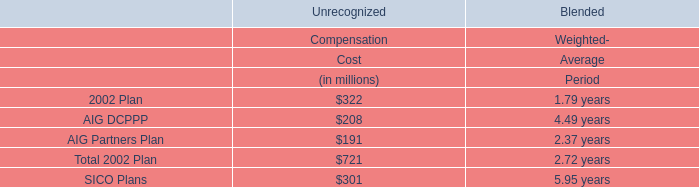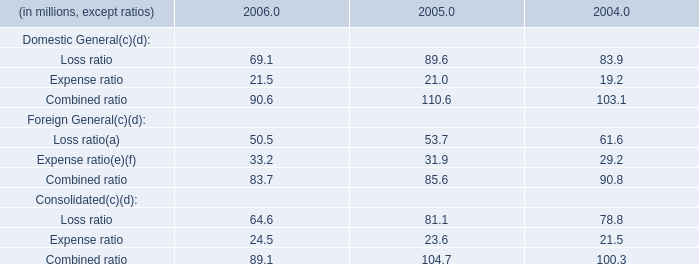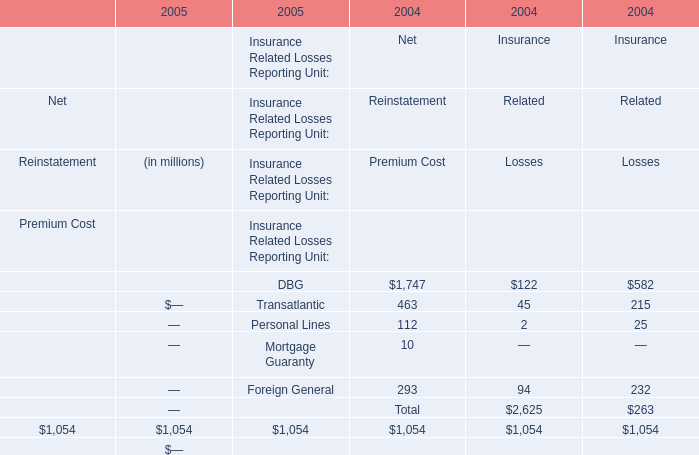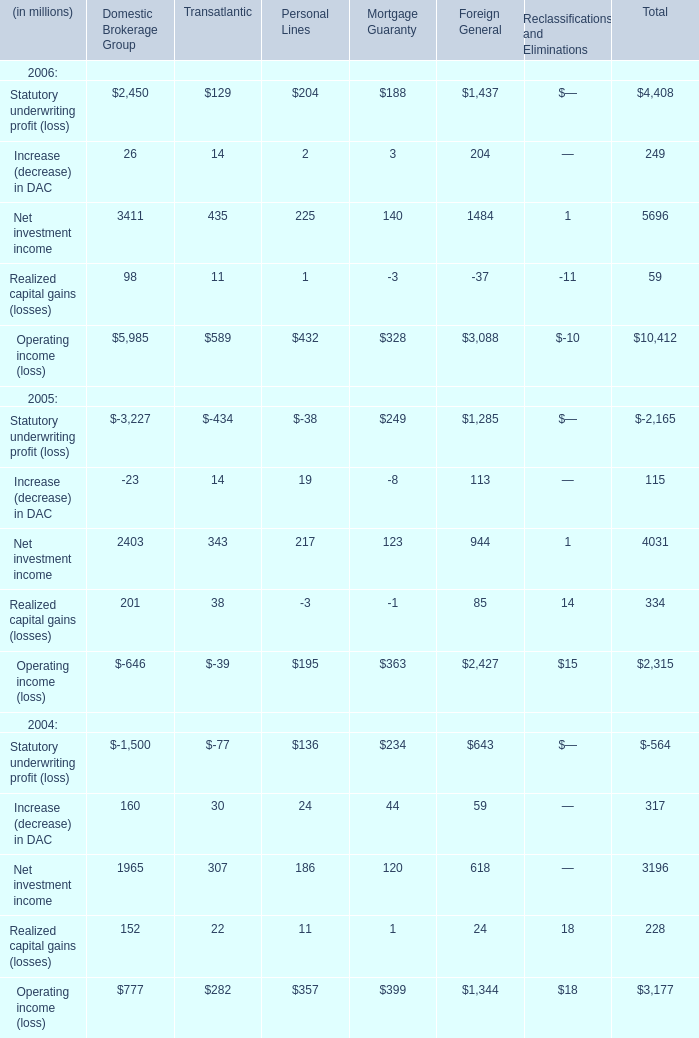Which year is Loss ratio of Consolidated the lowest? 
Answer: 2006. 